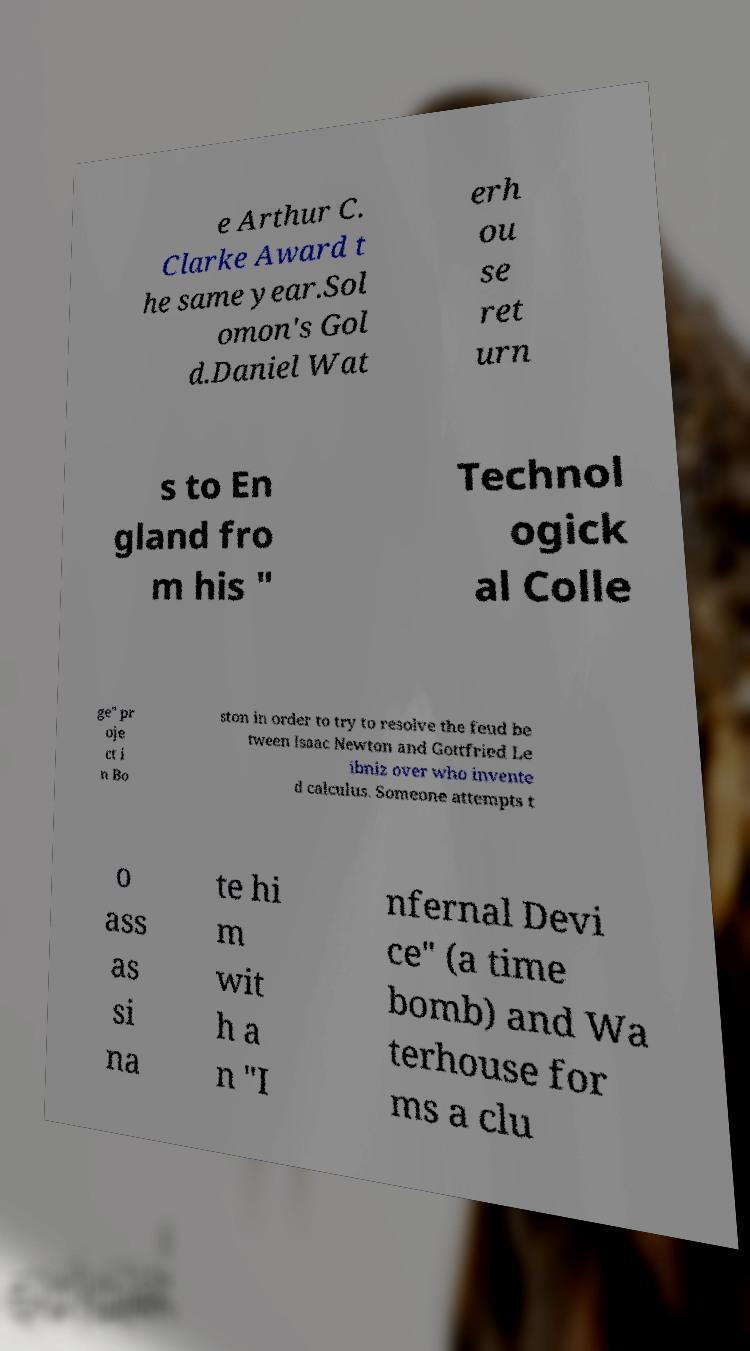Can you accurately transcribe the text from the provided image for me? e Arthur C. Clarke Award t he same year.Sol omon's Gol d.Daniel Wat erh ou se ret urn s to En gland fro m his " Technol ogick al Colle ge" pr oje ct i n Bo ston in order to try to resolve the feud be tween Isaac Newton and Gottfried Le ibniz over who invente d calculus. Someone attempts t o ass as si na te hi m wit h a n "I nfernal Devi ce" (a time bomb) and Wa terhouse for ms a clu 